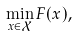Convert formula to latex. <formula><loc_0><loc_0><loc_500><loc_500>\min _ { x \in \mathcal { X } } F ( x ) ,</formula> 